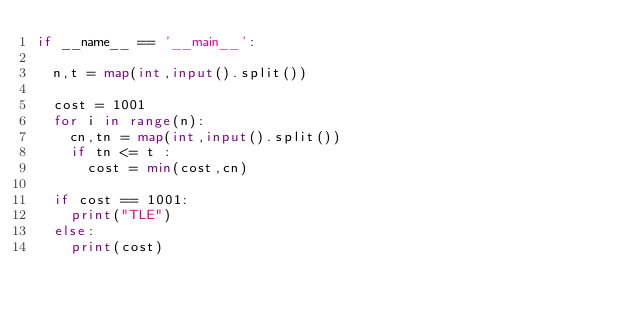<code> <loc_0><loc_0><loc_500><loc_500><_Python_>if __name__ == '__main__':

	n,t = map(int,input().split())
	
	cost = 1001
	for i in range(n):
		cn,tn = map(int,input().split())
		if tn <= t :
			cost = min(cost,cn)

	if cost == 1001:
		print("TLE")
	else:
		print(cost)
</code> 